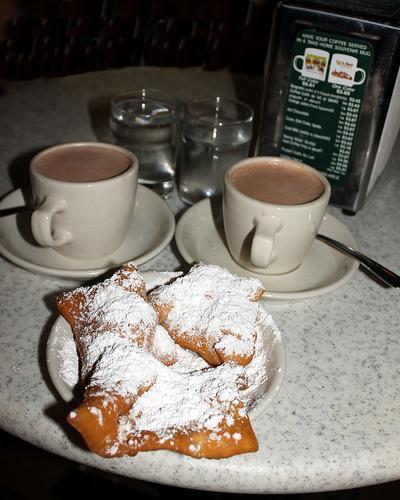How many water glasses are there?
Give a very brief answer. 2. How many women are there?
Give a very brief answer. 0. 